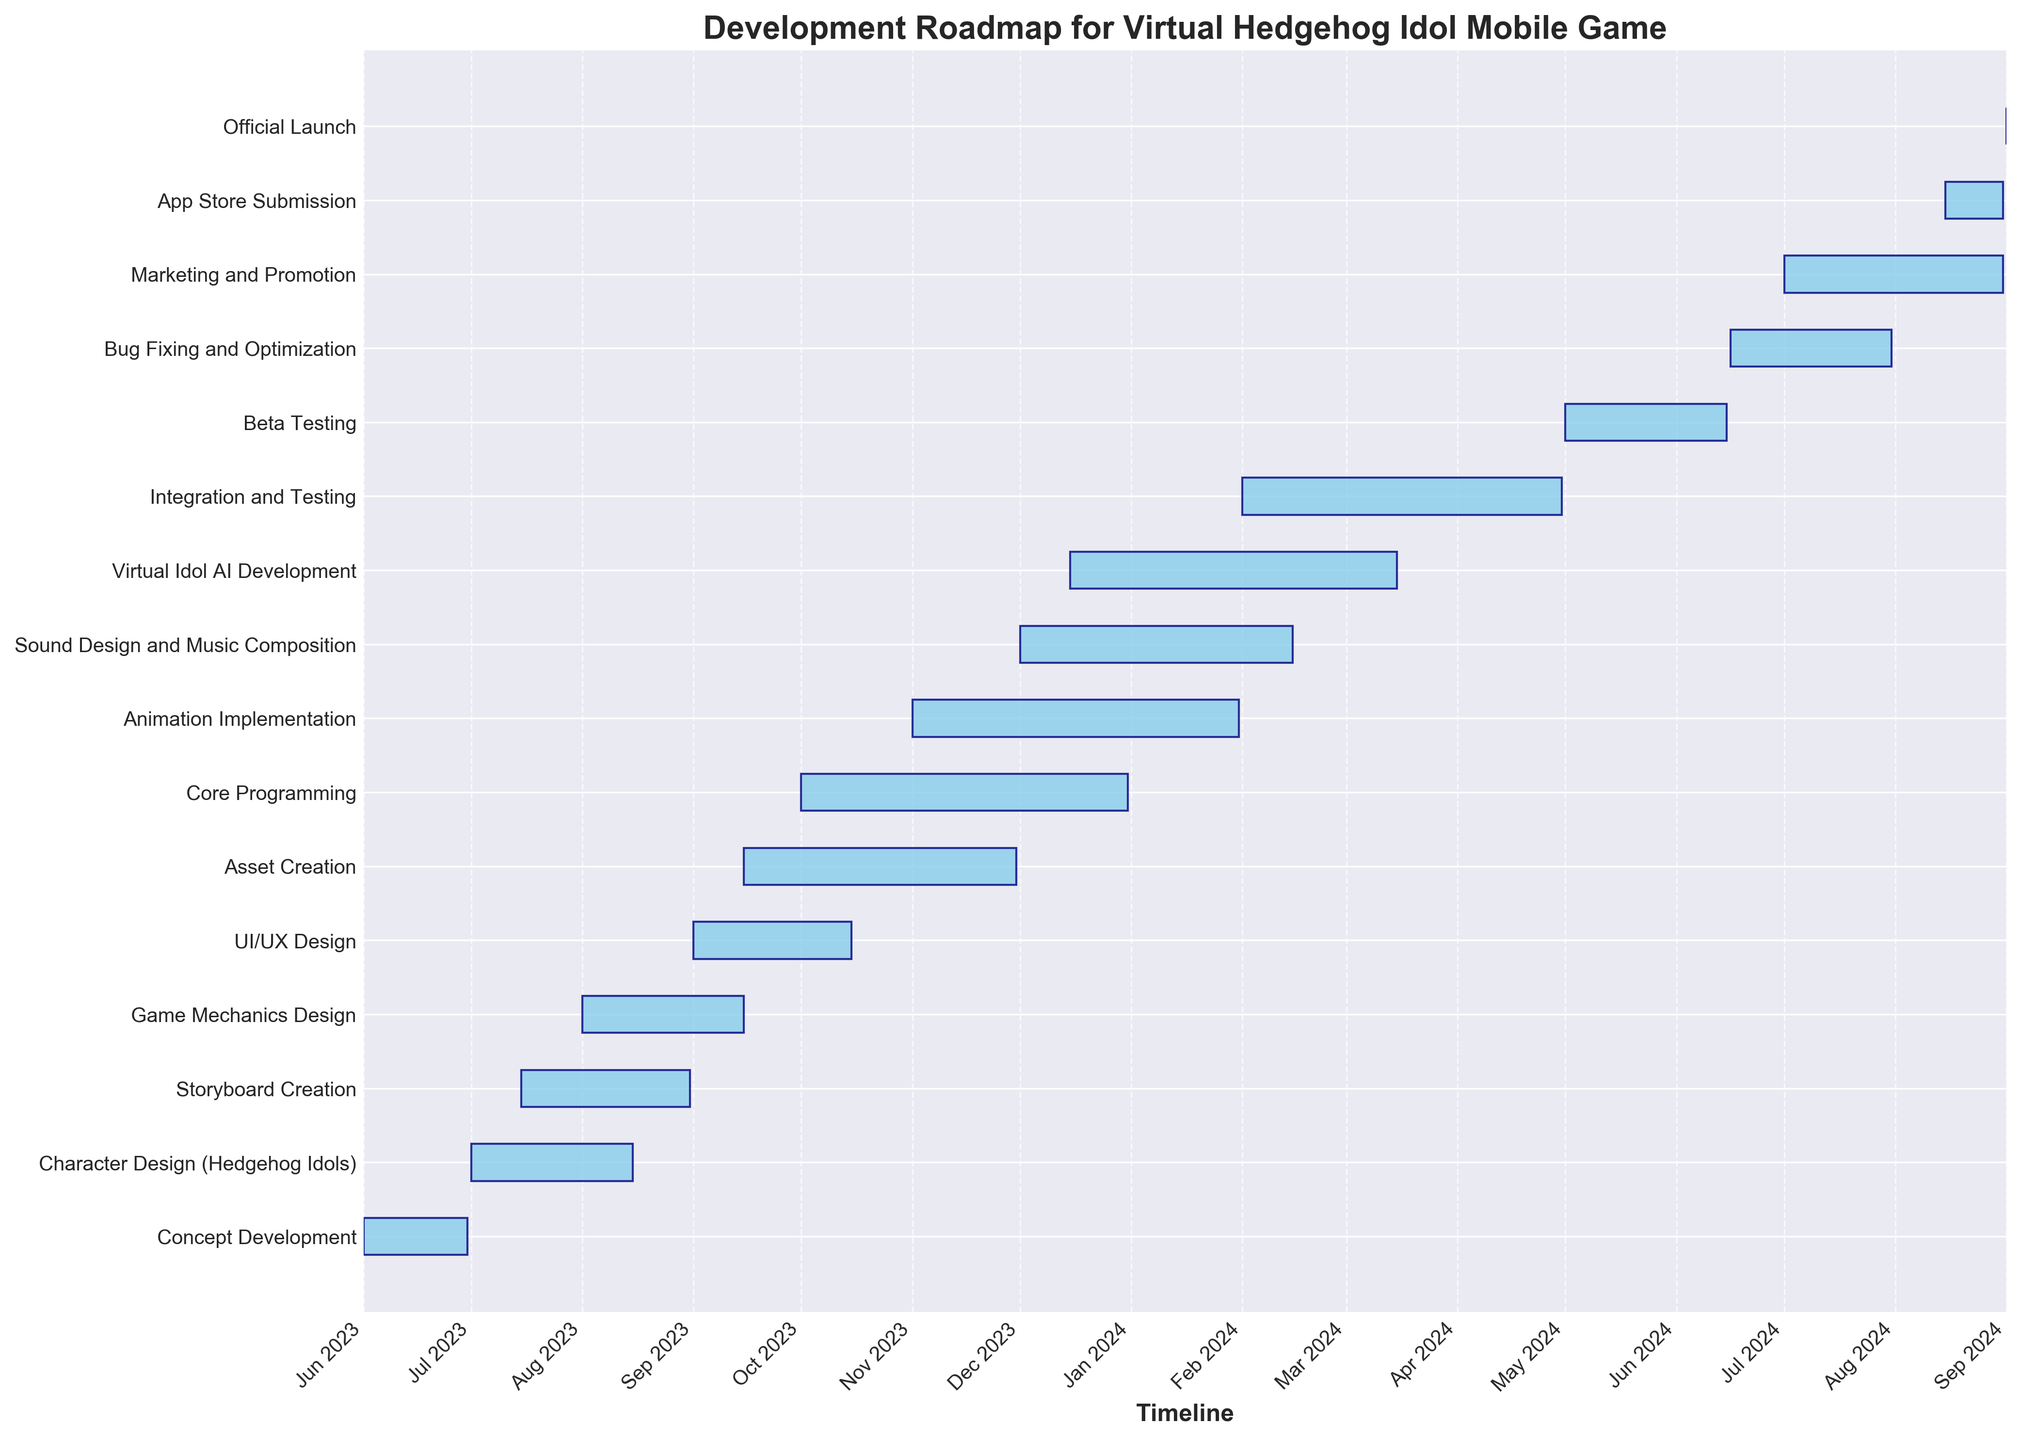what is the title of the figure? The title of the figure is usually located at the top center of the chart. In this case, the title reads "Development Roadmap for Virtual Hedgehog Idol Mobile Game."
Answer: Development Roadmap for Virtual Hedgehog Idol Mobile Game When does the Character Design phase start? The start date for the Character Design task can be found in the figure. It starts on 2023-07-01.
Answer: 2023-07-01 How long does the Core Programming phase last? The duration of the Core Programming phase can be identified by looking at the length of the bar for that task. It lasts 92 days.
Answer: 92 days Which task ends the latest in the timeline? By looking at the end dates of all the tasks, we can see that the Virtual Idol AI Development ends on 2024-03-15, making it the last task to end before the official launch preparations.
Answer: Virtual Idol AI Development How many tasks are scheduled to start in December 2023? To find this out, we can look at the start dates for each task and count how many tasks begin in December 2023. The tasks are "Sound Design and Music Composition" and "Virtual Idol AI Development."
Answer: 2 Which tasks overlap with the Animation Implementation phase? By examining the start and end dates of tasks that coincide with the Animation Implementation phase (2023-11-01 to 2024-01-31), the overlapping tasks are "Core Programming," "Asset Creation," "Sound Design and Music Composition," and "Virtual Idol AI Development."
Answer: Core Programming, Asset Creation, Sound Design and Music Composition, Virtual Idol AI Development What is the total duration of the testing phases (Integration and Testing + Beta Testing)? The Integration and Testing phase lasts 90 days, and the Beta Testing phase lasts 46 days. Adding these together, the total duration is 90 + 46 = 136 days.
Answer: 136 days What is the shortest task on the Gantt Chart? By observing the chart and identifying the shortest bar, we can see that the shortest task is "Official Launch," which only lasts for 1 day.
Answer: Official Launch How does the start date of the marketing phase compare to the end date of Beta Testing? The Marketing and Promotion phase starts on 2024-07-01, while the Beta Testing ends on 2024-06-15. Thus, marketing starts shortly after beta testing ends.
Answer: Shortly after 